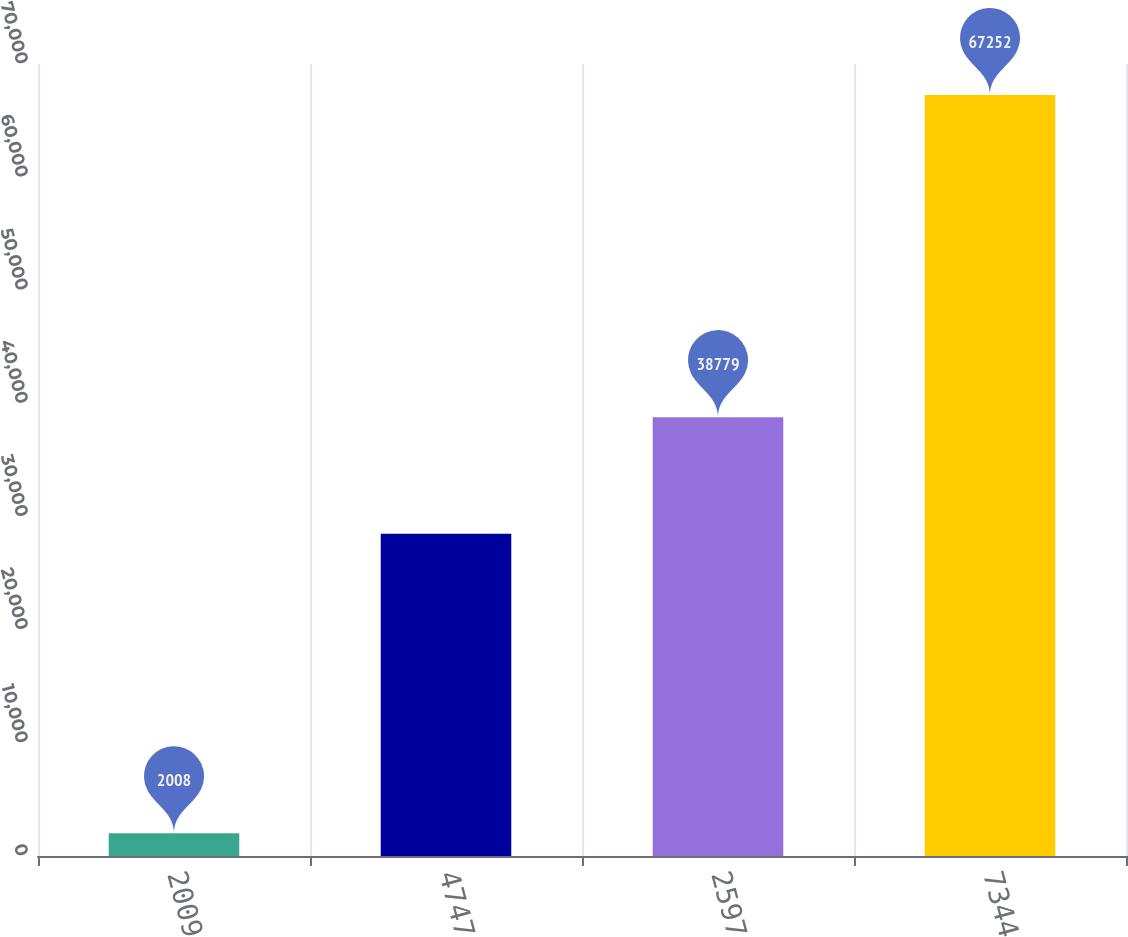<chart> <loc_0><loc_0><loc_500><loc_500><bar_chart><fcel>2009<fcel>4747<fcel>2597<fcel>7344<nl><fcel>2008<fcel>28473<fcel>38779<fcel>67252<nl></chart> 